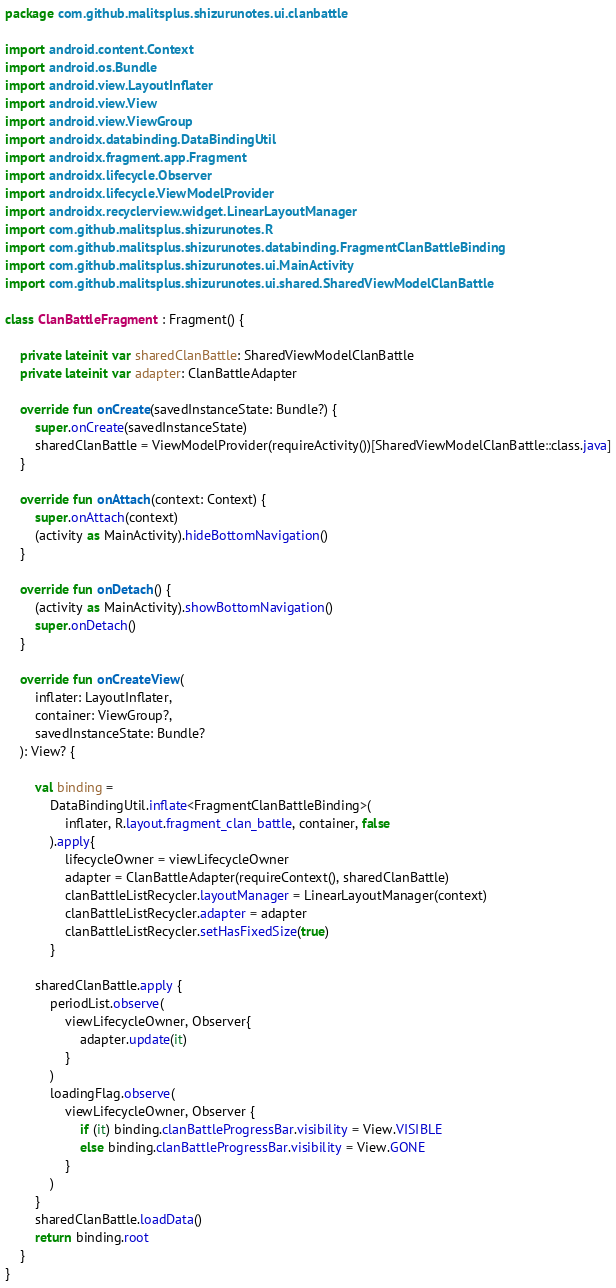<code> <loc_0><loc_0><loc_500><loc_500><_Kotlin_>package com.github.malitsplus.shizurunotes.ui.clanbattle

import android.content.Context
import android.os.Bundle
import android.view.LayoutInflater
import android.view.View
import android.view.ViewGroup
import androidx.databinding.DataBindingUtil
import androidx.fragment.app.Fragment
import androidx.lifecycle.Observer
import androidx.lifecycle.ViewModelProvider
import androidx.recyclerview.widget.LinearLayoutManager
import com.github.malitsplus.shizurunotes.R
import com.github.malitsplus.shizurunotes.databinding.FragmentClanBattleBinding
import com.github.malitsplus.shizurunotes.ui.MainActivity
import com.github.malitsplus.shizurunotes.ui.shared.SharedViewModelClanBattle

class ClanBattleFragment : Fragment() {

    private lateinit var sharedClanBattle: SharedViewModelClanBattle
    private lateinit var adapter: ClanBattleAdapter

    override fun onCreate(savedInstanceState: Bundle?) {
        super.onCreate(savedInstanceState)
        sharedClanBattle = ViewModelProvider(requireActivity())[SharedViewModelClanBattle::class.java]
    }

    override fun onAttach(context: Context) {
        super.onAttach(context)
        (activity as MainActivity).hideBottomNavigation()
    }

    override fun onDetach() {
        (activity as MainActivity).showBottomNavigation()
        super.onDetach()
    }

    override fun onCreateView(
        inflater: LayoutInflater,
        container: ViewGroup?,
        savedInstanceState: Bundle?
    ): View? {

        val binding =
            DataBindingUtil.inflate<FragmentClanBattleBinding>(
                inflater, R.layout.fragment_clan_battle, container, false
            ).apply{
                lifecycleOwner = viewLifecycleOwner
                adapter = ClanBattleAdapter(requireContext(), sharedClanBattle)
                clanBattleListRecycler.layoutManager = LinearLayoutManager(context)
                clanBattleListRecycler.adapter = adapter
                clanBattleListRecycler.setHasFixedSize(true)
            }

        sharedClanBattle.apply {
            periodList.observe(
                viewLifecycleOwner, Observer{
                    adapter.update(it)
                }
            )
            loadingFlag.observe(
                viewLifecycleOwner, Observer {
                    if (it) binding.clanBattleProgressBar.visibility = View.VISIBLE
                    else binding.clanBattleProgressBar.visibility = View.GONE
                }
            )
        }
        sharedClanBattle.loadData()
        return binding.root
    }
}</code> 